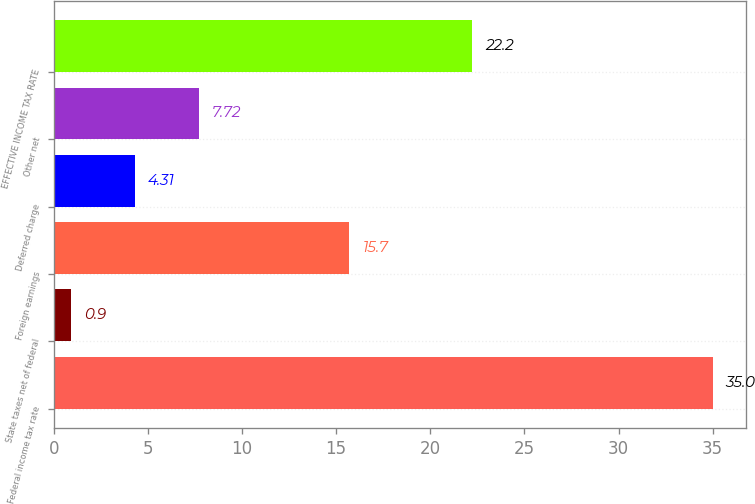<chart> <loc_0><loc_0><loc_500><loc_500><bar_chart><fcel>Federal income tax rate<fcel>State taxes net of federal<fcel>Foreign earnings<fcel>Deferred charge<fcel>Other net<fcel>EFFECTIVE INCOME TAX RATE<nl><fcel>35<fcel>0.9<fcel>15.7<fcel>4.31<fcel>7.72<fcel>22.2<nl></chart> 